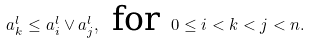<formula> <loc_0><loc_0><loc_500><loc_500>a _ { k } ^ { l } \leq a _ { i } ^ { l } \vee a _ { j } ^ { l } , \text { for } 0 \leq i < k < j < n .</formula> 